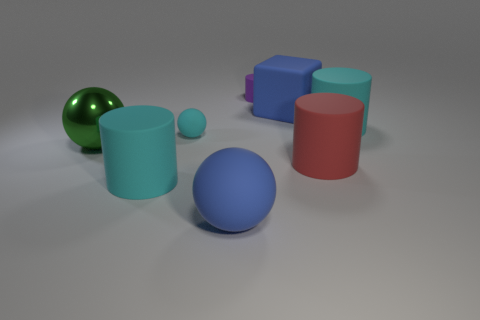There is a ball that is the same color as the block; what material is it?
Ensure brevity in your answer.  Rubber. There is a large matte thing that is both in front of the tiny cyan rubber sphere and on the right side of the purple rubber thing; what is its shape?
Offer a terse response. Cylinder. Does the cyan thing in front of the large metal ball have the same size as the blue matte thing to the right of the purple matte object?
Ensure brevity in your answer.  Yes. The blue thing that is the same material as the large blue ball is what shape?
Give a very brief answer. Cube. Is there any other thing that is the same shape as the big green object?
Your response must be concise. Yes. The object that is in front of the big cyan rubber object in front of the green thing that is to the left of the tiny cyan thing is what color?
Keep it short and to the point. Blue. Are there fewer large green shiny spheres that are behind the blue block than small cyan objects that are in front of the large red cylinder?
Your response must be concise. No. Is the shape of the metal object the same as the tiny cyan object?
Your response must be concise. Yes. How many cylinders are the same size as the blue cube?
Ensure brevity in your answer.  3. Are there fewer cylinders that are left of the tiny purple matte cylinder than gray rubber blocks?
Keep it short and to the point. No. 